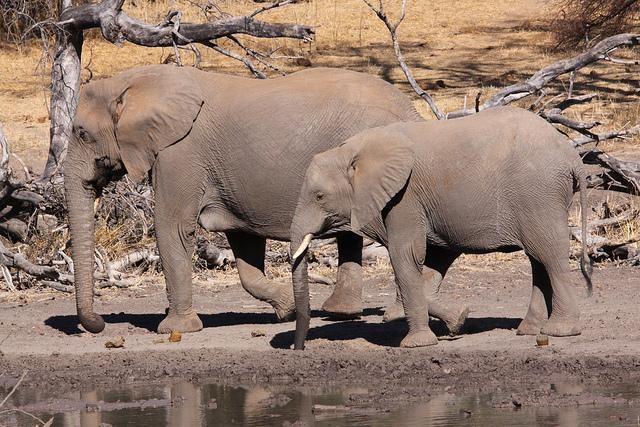How many animals are here?
Give a very brief answer. 2. How many elephants are in the photo?
Give a very brief answer. 2. 